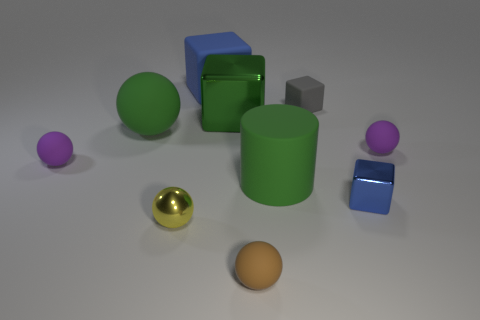Are there fewer spheres than big brown metallic objects?
Your response must be concise. No. What is the material of the blue thing that is the same size as the green ball?
Give a very brief answer. Rubber. There is a green metal cube on the left side of the small shiny block; is it the same size as the purple ball right of the yellow thing?
Keep it short and to the point. No. Is there a big cyan sphere that has the same material as the brown thing?
Offer a very short reply. No. What number of objects are either blue cubes to the left of the tiny blue shiny thing or purple rubber objects?
Make the answer very short. 3. Are the block that is to the left of the large green block and the small gray block made of the same material?
Your response must be concise. Yes. Does the small gray matte object have the same shape as the small yellow metal thing?
Give a very brief answer. No. How many small yellow shiny balls are to the left of the tiny ball right of the brown ball?
Make the answer very short. 1. There is a large blue object that is the same shape as the gray rubber object; what is its material?
Your answer should be compact. Rubber. There is a big matte thing behind the gray matte thing; is its color the same as the big matte cylinder?
Keep it short and to the point. No. 